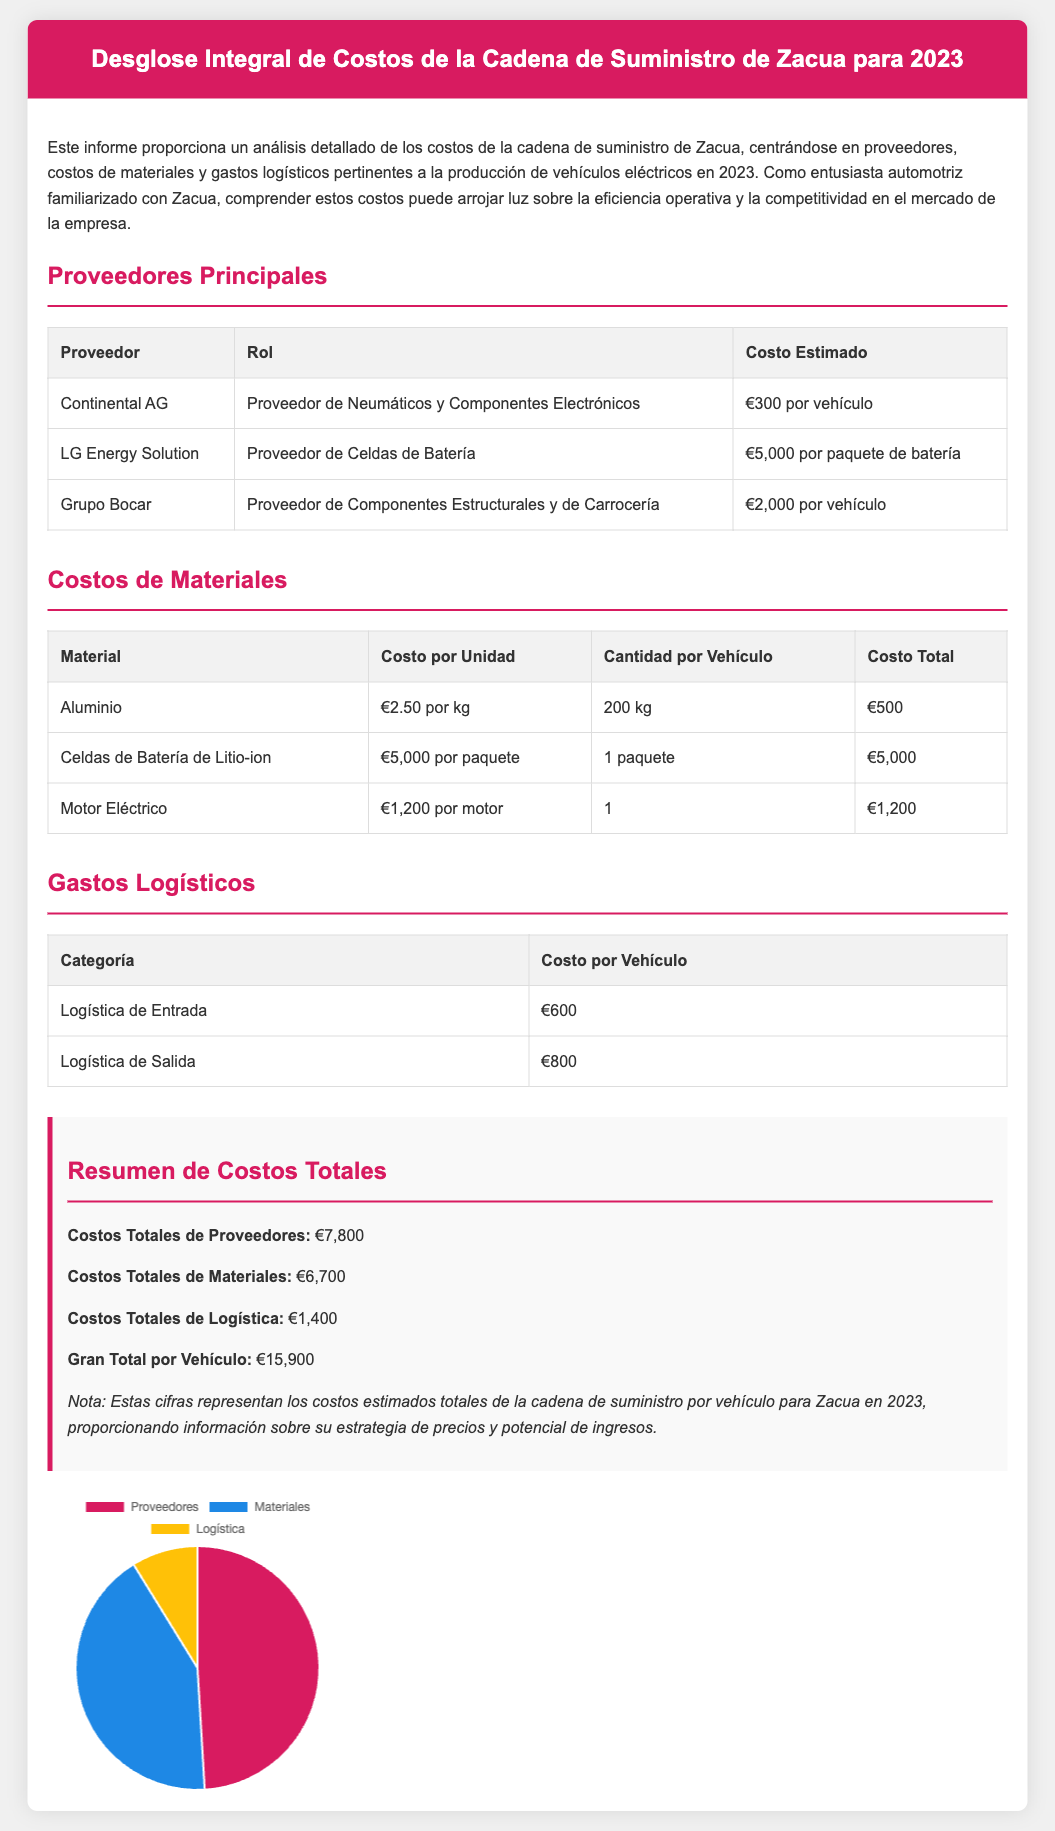¿Cuál es el costo de los neumáticos por vehículo? El costo de los neumáticos por vehículo es proporcionado en la sección de proveedores, específicamente para Continental AG.
Answer: €300 por vehículo ¿Cuánto cuesta un paquete de batería de LG Energy Solution? El costo de un paquete de batería de LG Energy Solution se menciona en la sección de proveedores.
Answer: €5,000 por paquete de batería ¿Cuántos kg de aluminio se requieren por vehículo? La cantidad de aluminio necesaria por vehículo está indicada en la tabla de costos de materiales.
Answer: 200 kg ¿Cuál es el costo total de los materiales? El costo total de los materiales es el total indicado en la sección de resumen de costos.
Answer: €6,700 ¿Cuántos euros se destinan a logística de salida por vehículo? La sección de gastos logísticos proporciona este costo específico.
Answer: €800 ¿Cuál es el gran total por vehículo según el resumen? El gran total por vehículo se detalla en la sección resumen de costos totales.
Answer: €15,900 ¿Cuál es el proveedor de componentes estructurales y de carrocería? El proveedor de componentes estructurales y de carrocería se encuentra en la tabla de proveedores.
Answer: Grupo Bocar ¿Qué porcentaje del costo total por vehículo corresponde a los gastos logísticos? Para calcular este porcentaje, se debe considerar el total de logística en relación al gran total.
Answer: 8.8% ¿Cuántos proveedores principales se enumeran en el informe? La tabla de proveedores principales menciona cuántos proveedores están listados.
Answer: 3 ¿Qué tipo de gráfico se utiliza para mostrar la distribución de costos? El tipo de gráfico utilizado para mostrar la distribución de costos se menciona en la parte inferior del documento.
Answer: Pie Chart 